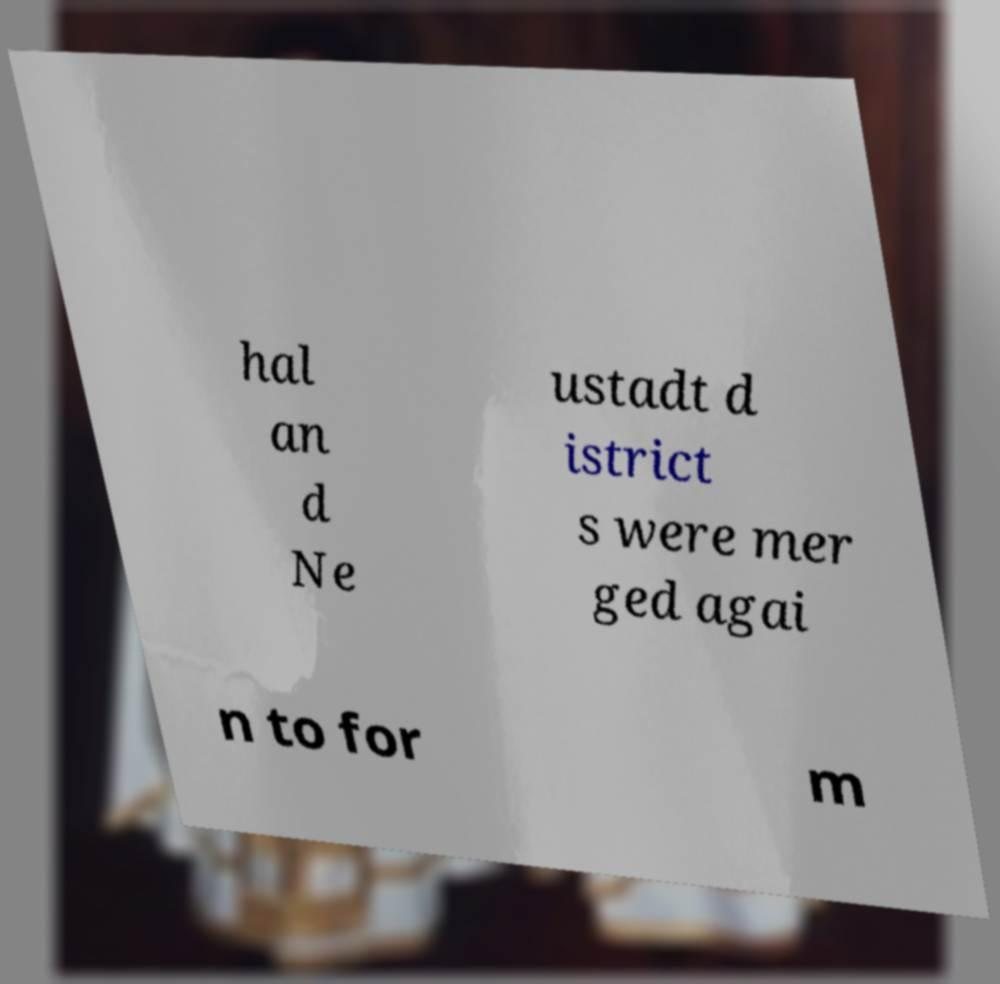Please identify and transcribe the text found in this image. hal an d Ne ustadt d istrict s were mer ged agai n to for m 